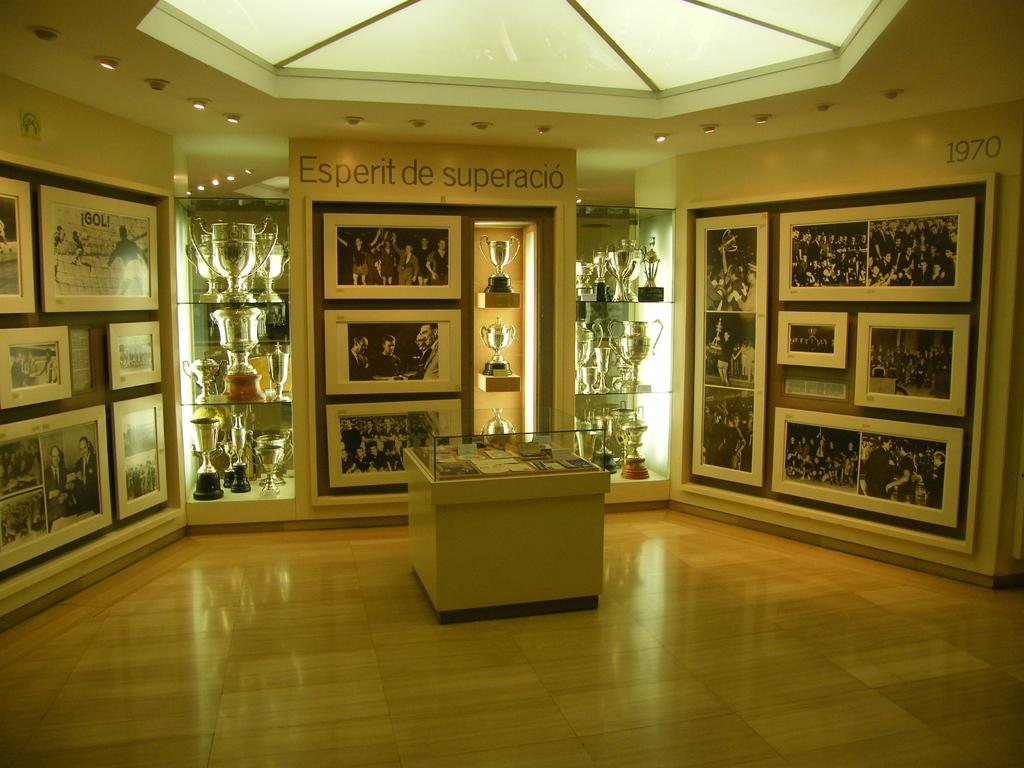What type of objects are located on both sides of the image? There are metals on both the right and left sides of the image. What other items can be seen in the image besides the metals? There are photo frames in the image. How are the photo frames arranged in the image? The photo frames are pasted in various locations. What is visible at the top of the image? There are lights on the top of the image. How does the pencil contribute to the pollution in the image? There is no pencil present in the image, so it cannot contribute to any pollution. 